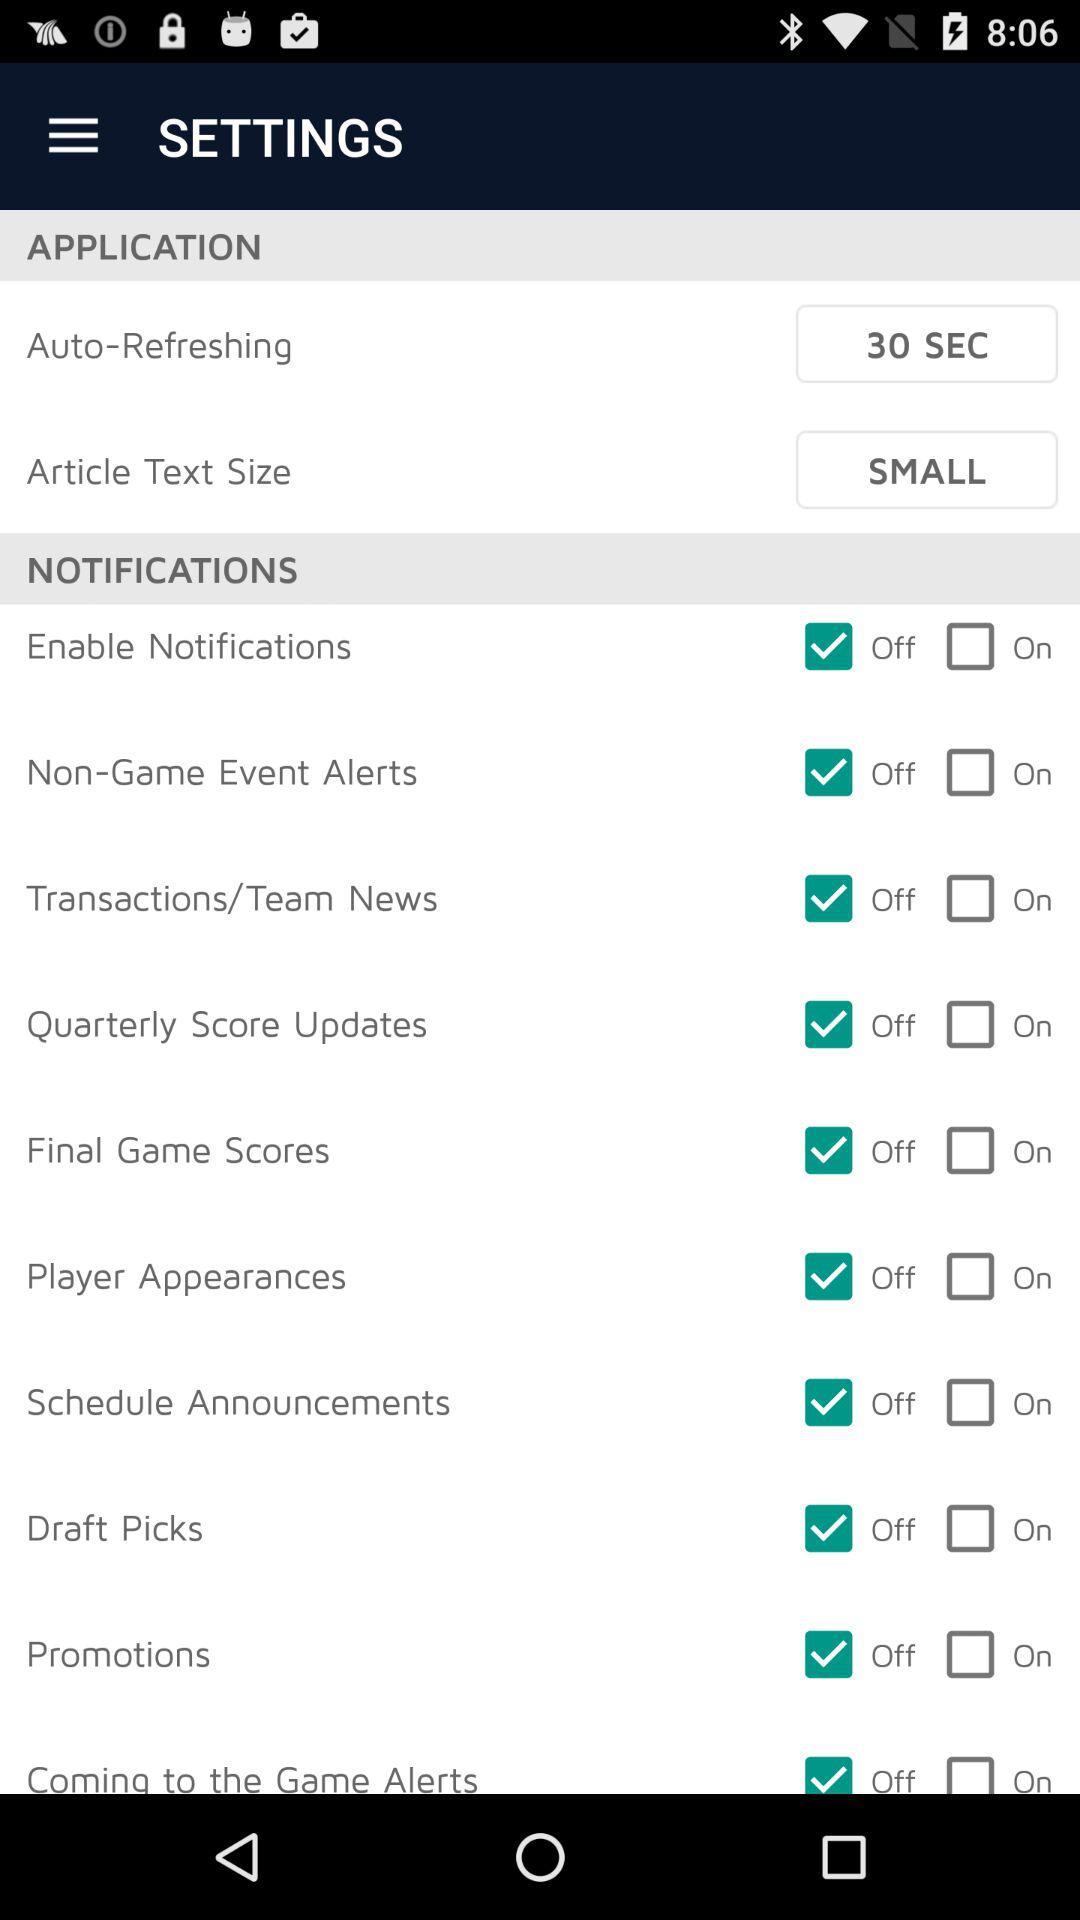How many checkboxes are in the Notifications section?
Answer the question using a single word or phrase. 10 